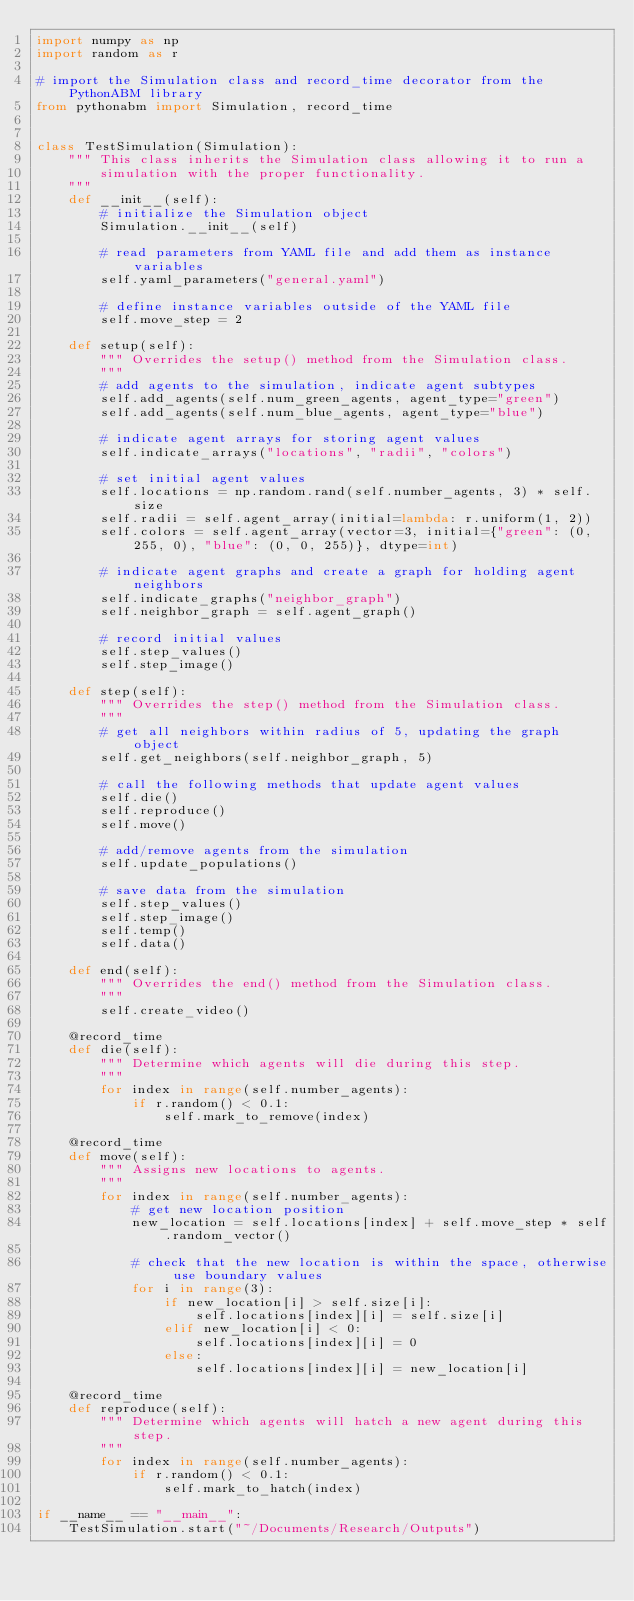Convert code to text. <code><loc_0><loc_0><loc_500><loc_500><_Python_>import numpy as np
import random as r

# import the Simulation class and record_time decorator from the PythonABM library
from pythonabm import Simulation, record_time


class TestSimulation(Simulation):
    """ This class inherits the Simulation class allowing it to run a
        simulation with the proper functionality.
    """
    def __init__(self):
        # initialize the Simulation object
        Simulation.__init__(self)

        # read parameters from YAML file and add them as instance variables
        self.yaml_parameters("general.yaml")

        # define instance variables outside of the YAML file
        self.move_step = 2

    def setup(self):
        """ Overrides the setup() method from the Simulation class.
        """
        # add agents to the simulation, indicate agent subtypes
        self.add_agents(self.num_green_agents, agent_type="green")
        self.add_agents(self.num_blue_agents, agent_type="blue")

        # indicate agent arrays for storing agent values
        self.indicate_arrays("locations", "radii", "colors")

        # set initial agent values
        self.locations = np.random.rand(self.number_agents, 3) * self.size
        self.radii = self.agent_array(initial=lambda: r.uniform(1, 2))
        self.colors = self.agent_array(vector=3, initial={"green": (0, 255, 0), "blue": (0, 0, 255)}, dtype=int)

        # indicate agent graphs and create a graph for holding agent neighbors
        self.indicate_graphs("neighbor_graph")
        self.neighbor_graph = self.agent_graph()

        # record initial values
        self.step_values()
        self.step_image()

    def step(self):
        """ Overrides the step() method from the Simulation class.
        """
        # get all neighbors within radius of 5, updating the graph object
        self.get_neighbors(self.neighbor_graph, 5)

        # call the following methods that update agent values
        self.die()
        self.reproduce()
        self.move()

        # add/remove agents from the simulation
        self.update_populations()

        # save data from the simulation
        self.step_values()
        self.step_image()
        self.temp()
        self.data()

    def end(self):
        """ Overrides the end() method from the Simulation class.
        """
        self.create_video()

    @record_time
    def die(self):
        """ Determine which agents will die during this step.
        """
        for index in range(self.number_agents):
            if r.random() < 0.1:
                self.mark_to_remove(index)

    @record_time
    def move(self):
        """ Assigns new locations to agents.
        """
        for index in range(self.number_agents):
            # get new location position
            new_location = self.locations[index] + self.move_step * self.random_vector()

            # check that the new location is within the space, otherwise use boundary values
            for i in range(3):
                if new_location[i] > self.size[i]:
                    self.locations[index][i] = self.size[i]
                elif new_location[i] < 0:
                    self.locations[index][i] = 0
                else:
                    self.locations[index][i] = new_location[i]

    @record_time
    def reproduce(self):
        """ Determine which agents will hatch a new agent during this step.
        """
        for index in range(self.number_agents):
            if r.random() < 0.1:
                self.mark_to_hatch(index)

if __name__ == "__main__":
    TestSimulation.start("~/Documents/Research/Outputs")
</code> 